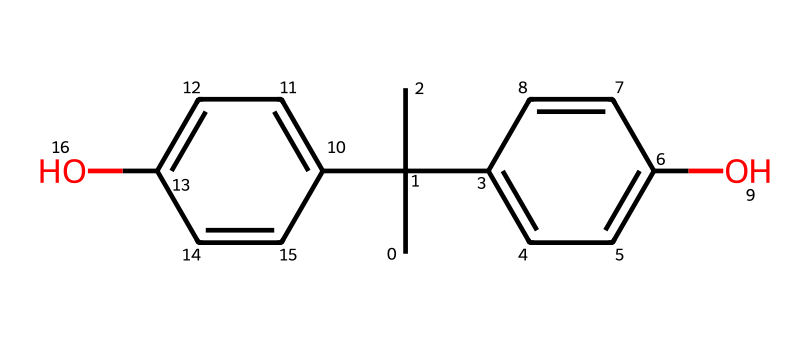What is the molecular formula of bisphenol A? By analyzing the SMILES representation, we can count the carbon (C), hydrogen (H), and oxygen (O) atoms present. The structure consists of 15 carbon, 16 hydrogen, and 2 oxygen, leading to the molecular formula C15H16O2.
Answer: C15H16O2 How many hydroxyl groups are present in bisphenol A? In the SMILES, we can observe two instances of 'O' directly attached to carbon atoms, indicating the presence of two hydroxyl (-OH) groups in the structure.
Answer: 2 What type of compounds does bisphenol A belong to? Bisphenol A is a synthetic compound used in the manufacturing of polycarbonate plastics and epoxy resins, categorizing it as an industrial chemical.
Answer: industrial chemical What is the total number of rings in the bisphenol A structure? Observing the SMILES, we note that there are two cyclic structures formed by the presence of the benzene rings in the molecule. Therefore, there are two rings.
Answer: 2 Is bisphenol A considered a hazardous chemical? Bisphenol A has been associated with potential endocrine-disrupting properties and other health risks, categorizing it as a hazardous chemical.
Answer: yes How many double bonds are present in bisphenol A? The structure of bisphenol A can be analyzed to identify double bonds between carbon atoms; in this molecule, there are six double bonds distributed mainly in the aromatic rings.
Answer: 6 